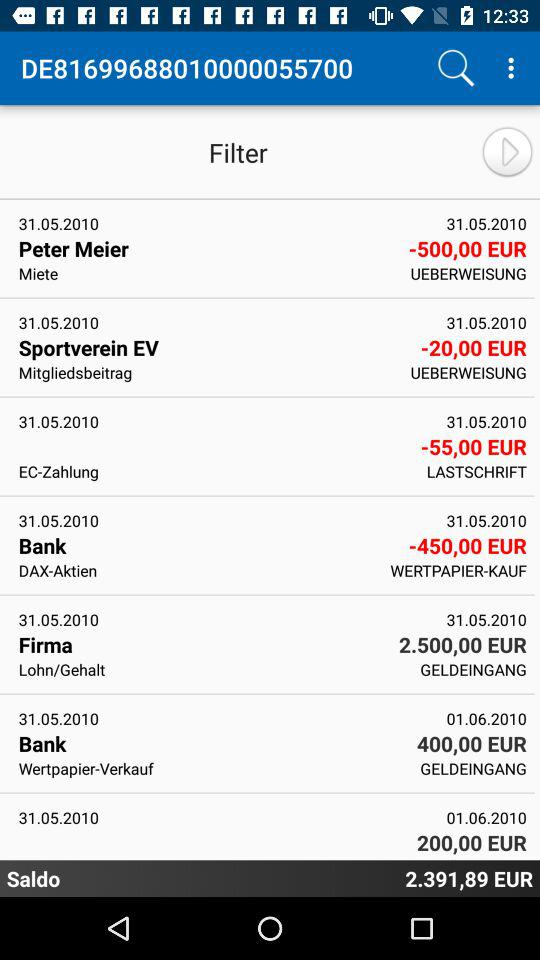What is the date for "Peter Meier"? The date for "Peter Meier" is May 31, 2010. 